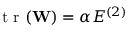<formula> <loc_0><loc_0><loc_500><loc_500>t r ( W ) = \alpha E ^ { ( 2 ) }</formula> 